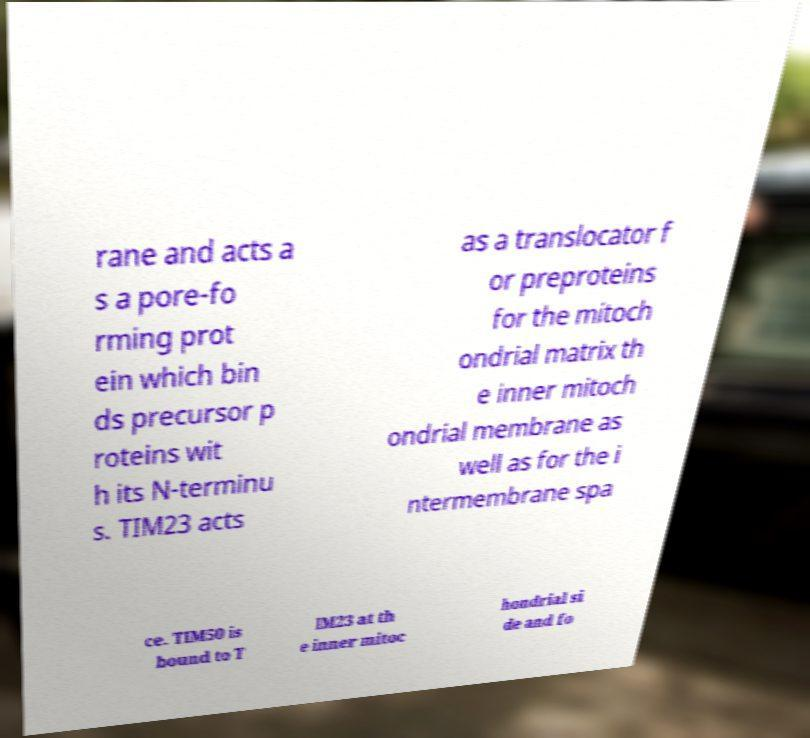Could you extract and type out the text from this image? rane and acts a s a pore-fo rming prot ein which bin ds precursor p roteins wit h its N-terminu s. TIM23 acts as a translocator f or preproteins for the mitoch ondrial matrix th e inner mitoch ondrial membrane as well as for the i ntermembrane spa ce. TIM50 is bound to T IM23 at th e inner mitoc hondrial si de and fo 